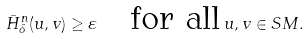Convert formula to latex. <formula><loc_0><loc_0><loc_500><loc_500>\bar { H } ^ { n } _ { \delta } ( u , v ) \geq \varepsilon \quad \text {for all} \, u , v \in S M .</formula> 